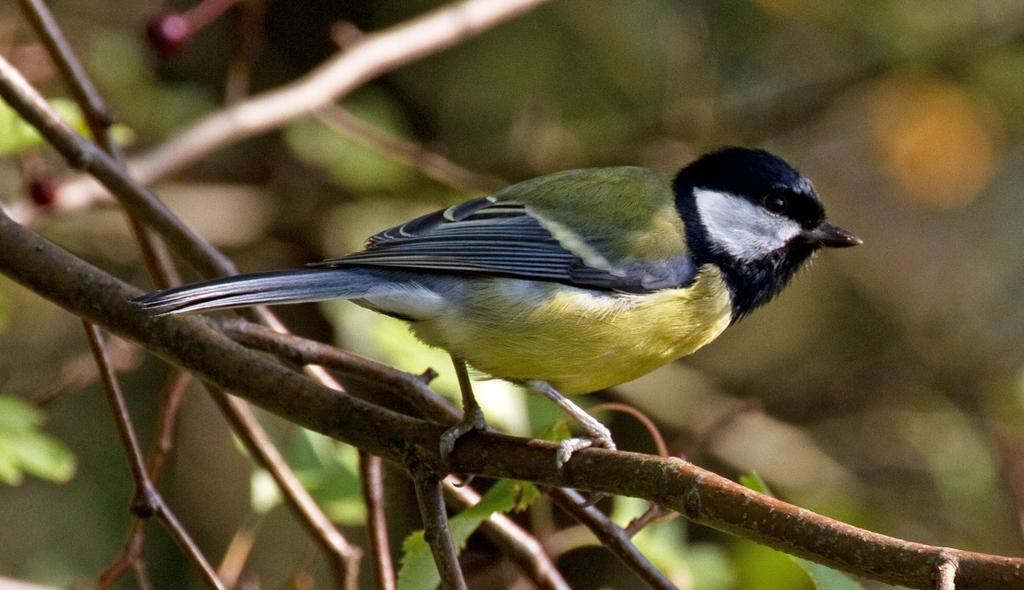What type of animal can be seen in the image? There is a bird in the image. Where is the bird located? The bird is standing on a tree stem. What else can be seen in the image besides the bird? There are leaves visible in the image. How would you describe the background of the image? The background has a blurred view. What type of education is the bird receiving in the image? There is no indication in the image that the bird is receiving any education. What kind of machine can be seen in the image? There are no machines present in the image; it features a bird standing on a tree stem with leaves in the background. 